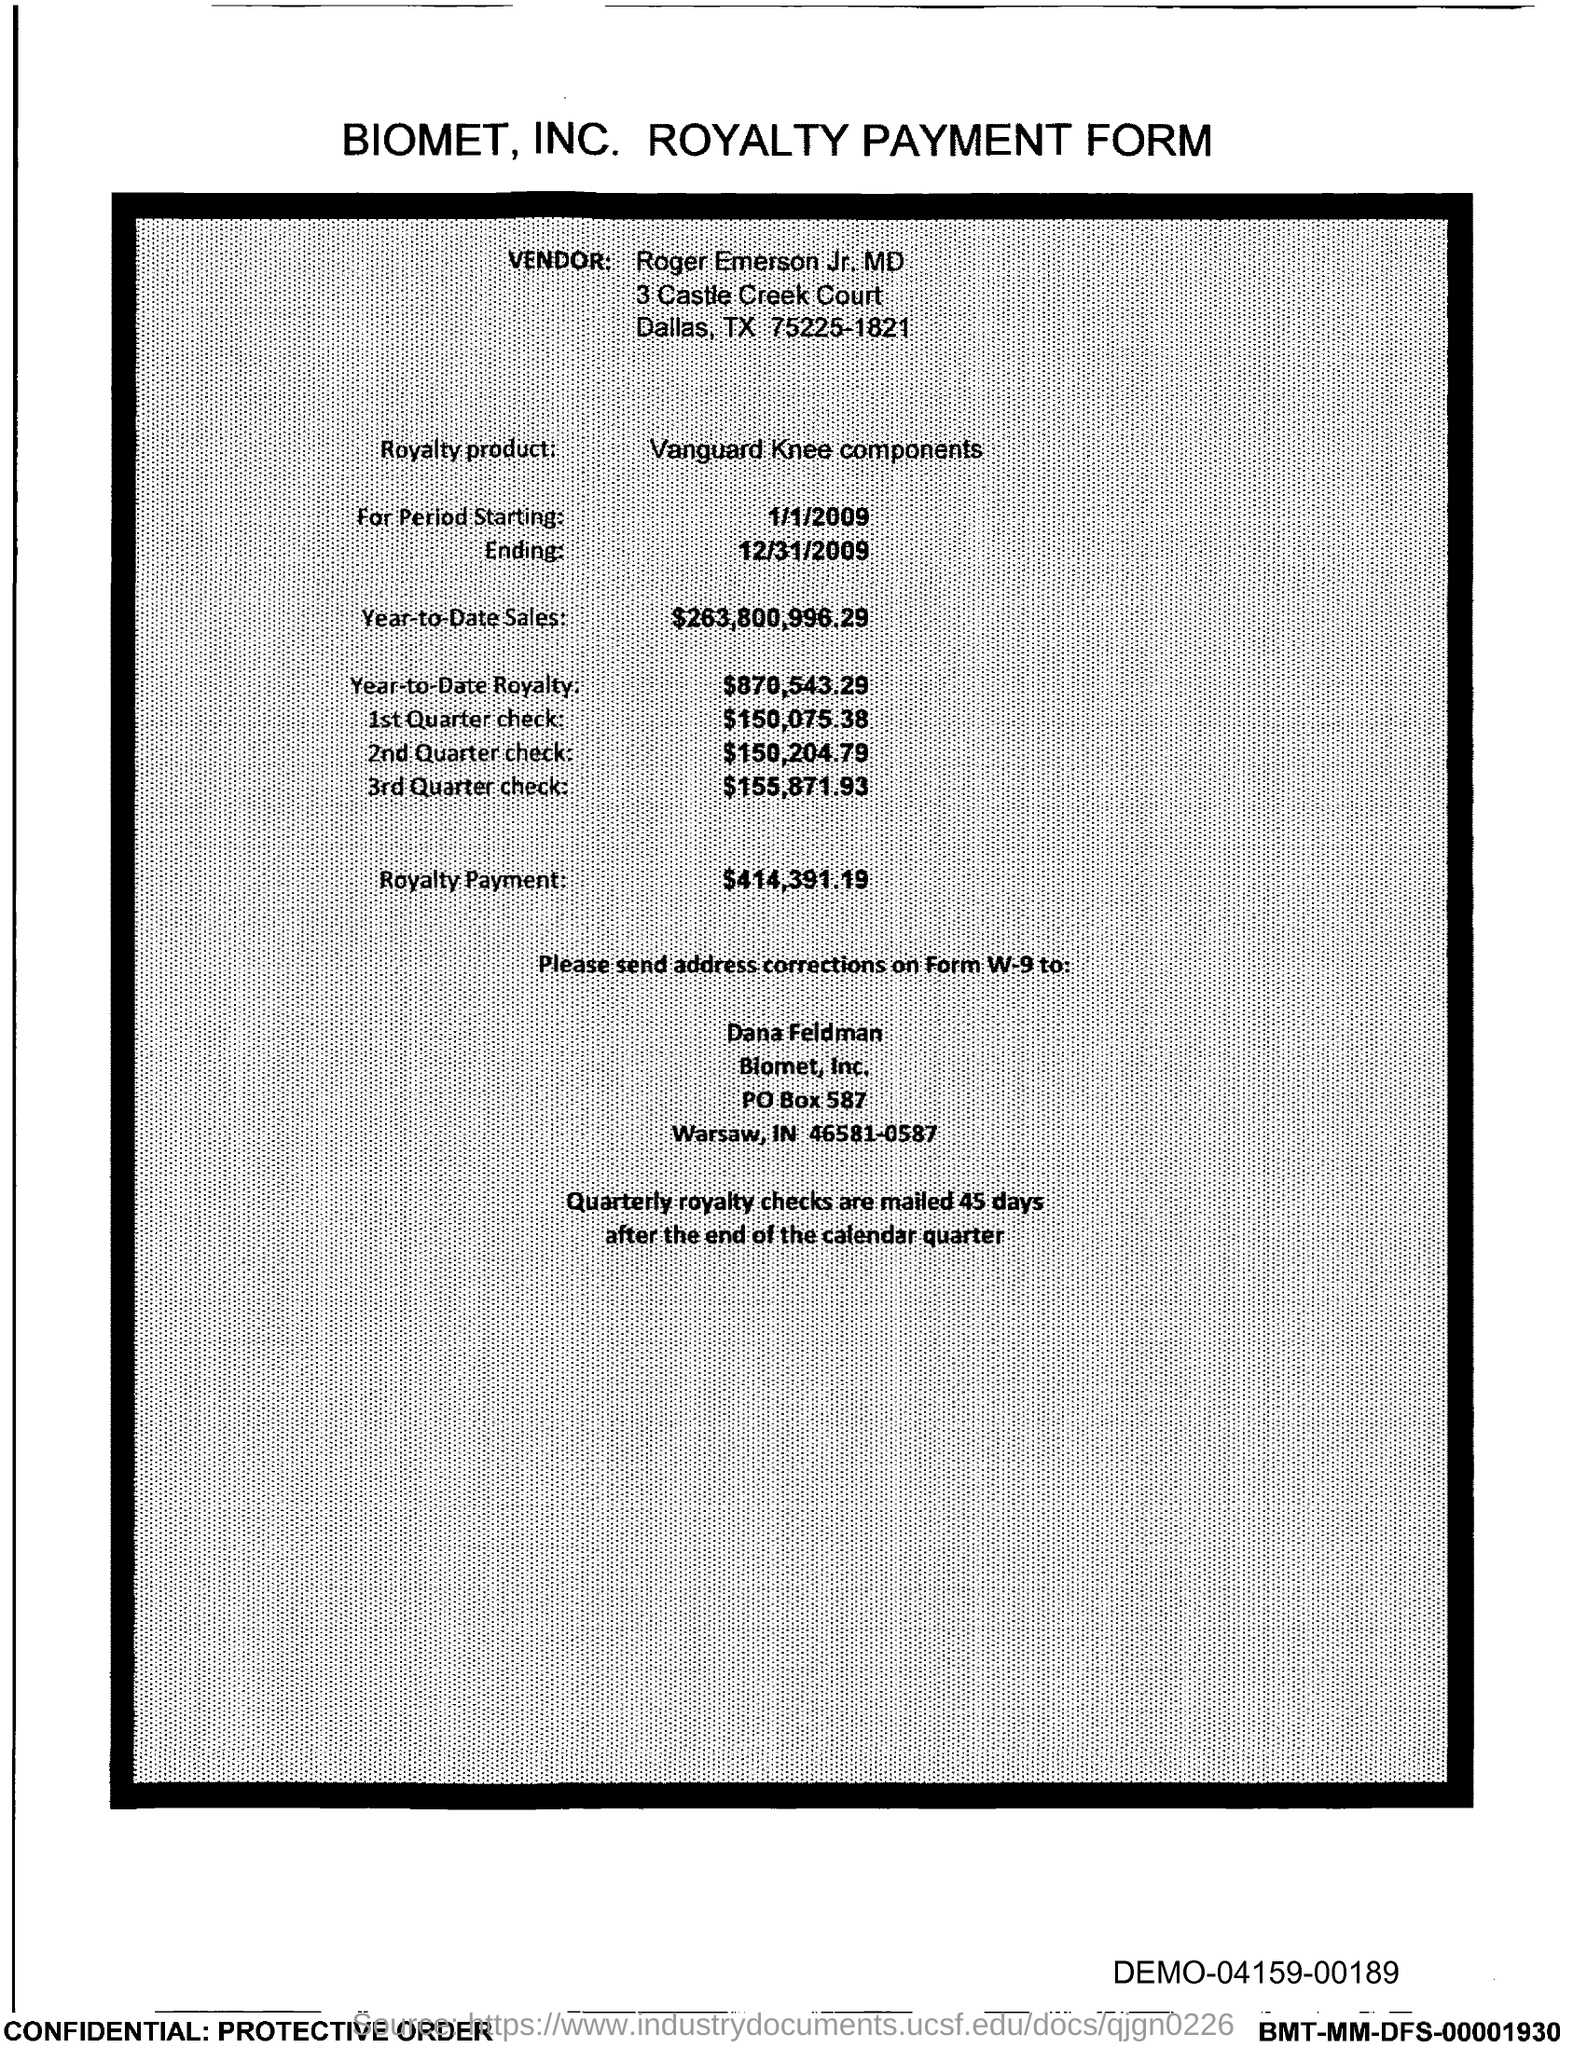Which company's royalty payment form is this?
Keep it short and to the point. Biomet, Inc. Who is the vendor mentioned in the form?
Your answer should be compact. Roger Emerson Jr. MD. What is the royalty product given in the form?
Make the answer very short. Vanguard Knee components. What is the Year-to-Date Sales of the royalty product?
Your answer should be very brief. 263,800,996.29. What is the Year-to-Date royalty of the product?
Give a very brief answer. $870,543.29. What is the amount of 3rd Quarter check given in the form?
Offer a terse response. 155,871.93. What is the amount of 2nd Quarter check mentioned in the form?
Offer a very short reply. $150,204.79. What is the amount of 1st quarter check mentioned in the form?
Keep it short and to the point. $150,075.38. When are the quartely royalty checks mailed?
Offer a terse response. 45 days after the end of the calendar quarter. What is the royalty payment of the product mentioned in the form?
Your response must be concise. $414,391.19. 